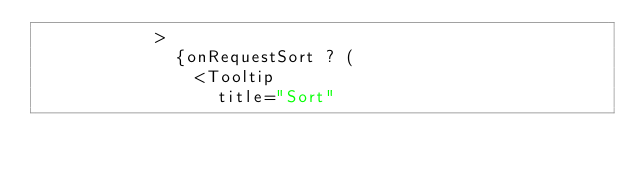Convert code to text. <code><loc_0><loc_0><loc_500><loc_500><_JavaScript_>            >
              {onRequestSort ? (
                <Tooltip
                  title="Sort"</code> 